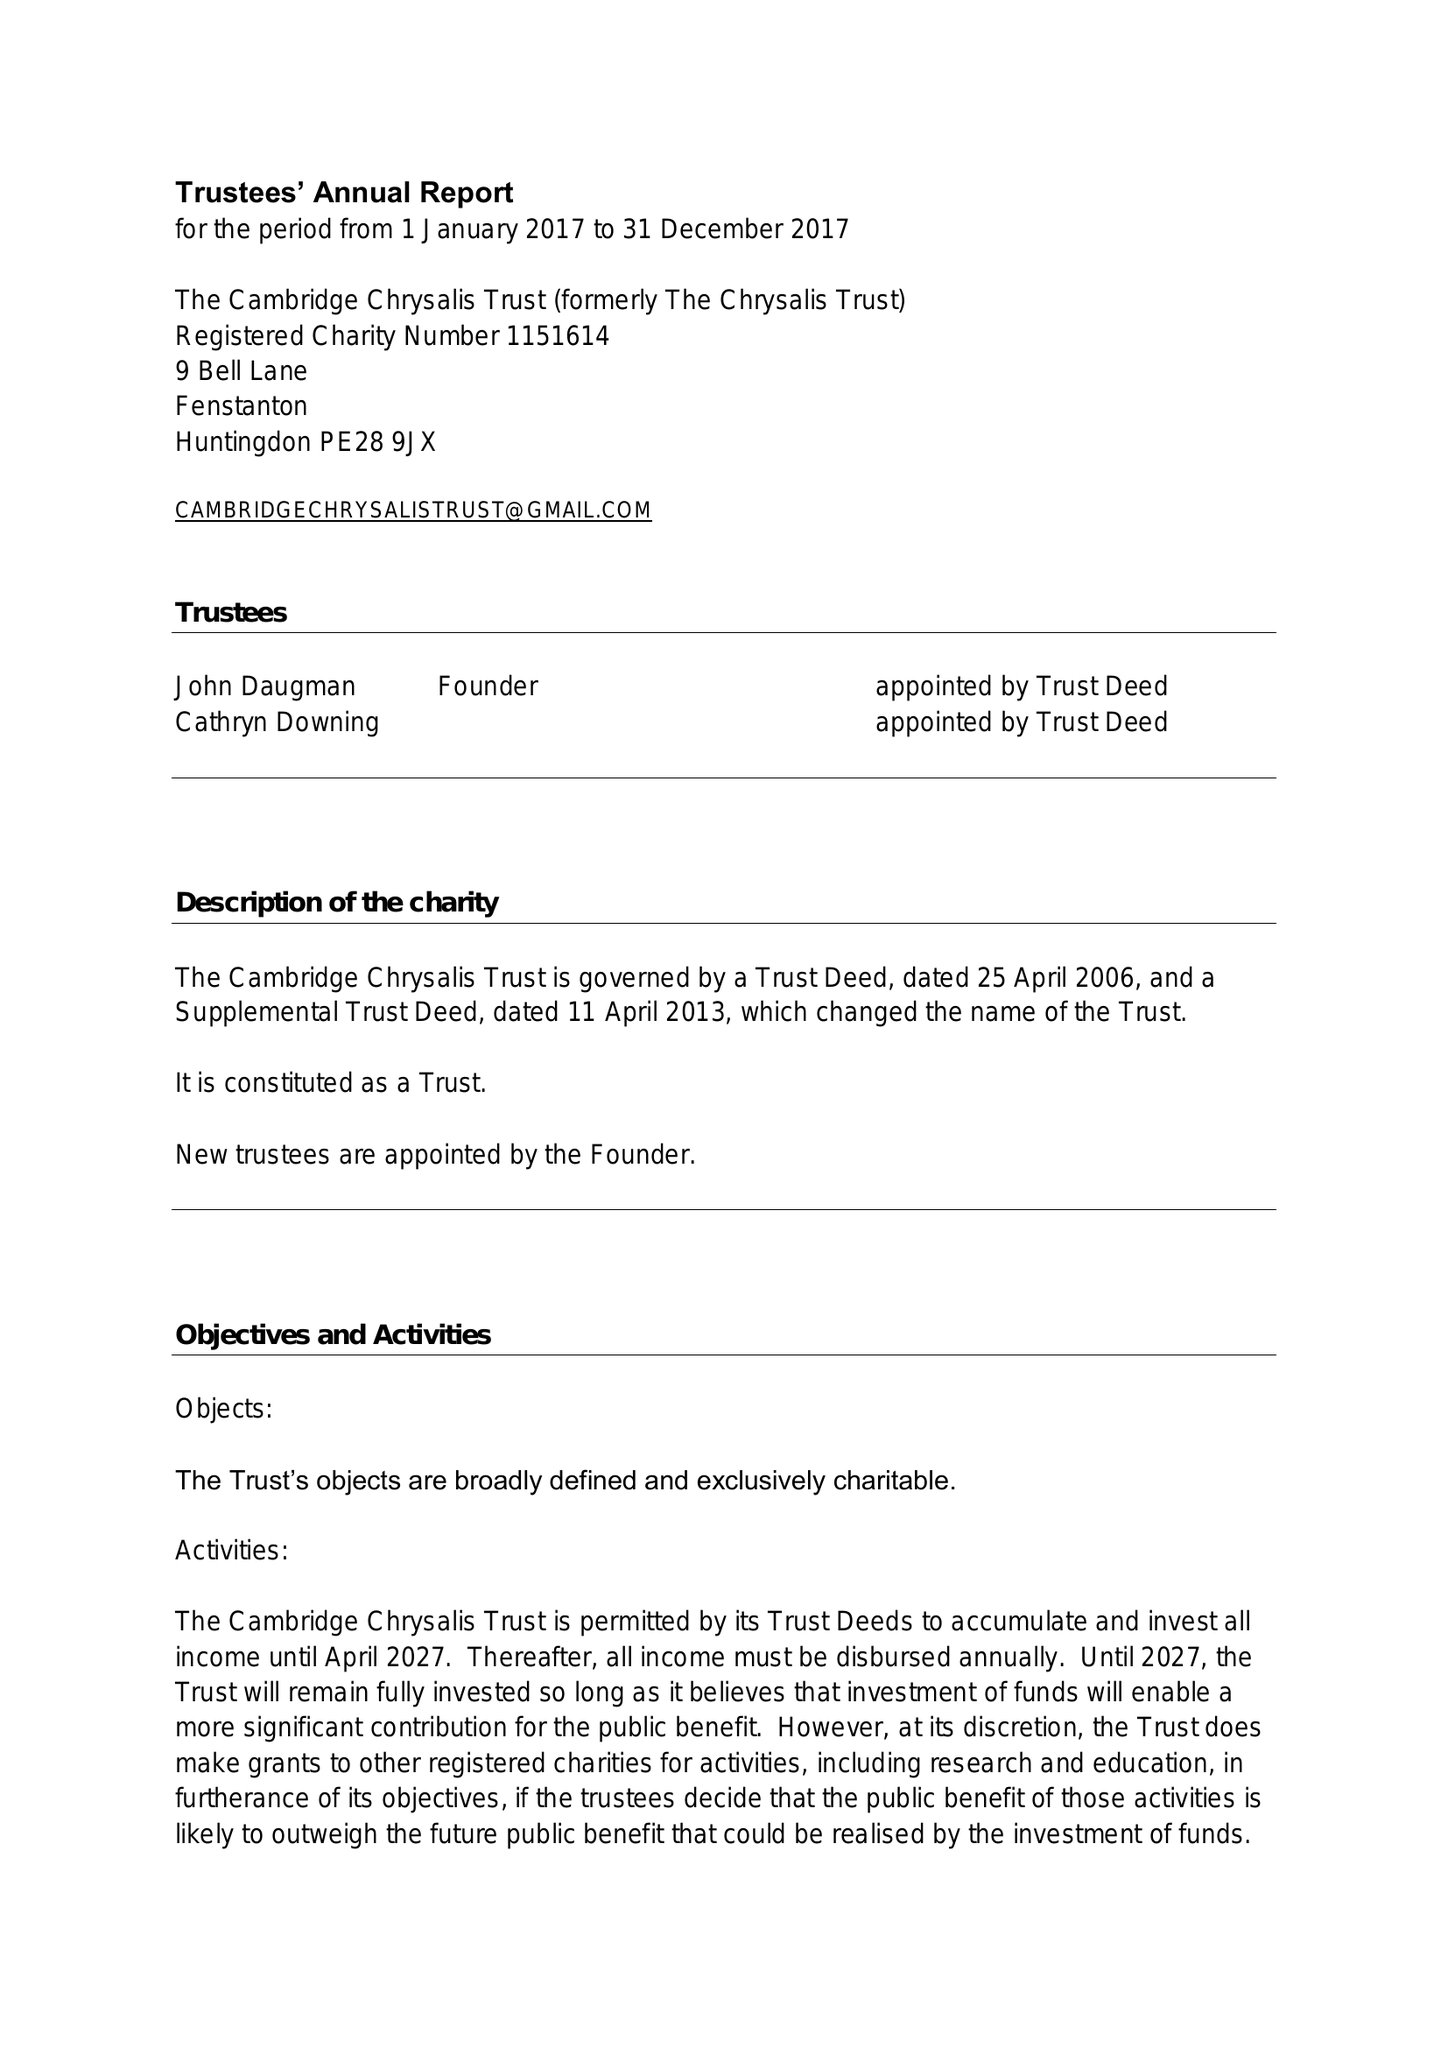What is the value for the report_date?
Answer the question using a single word or phrase. 2017-12-31 